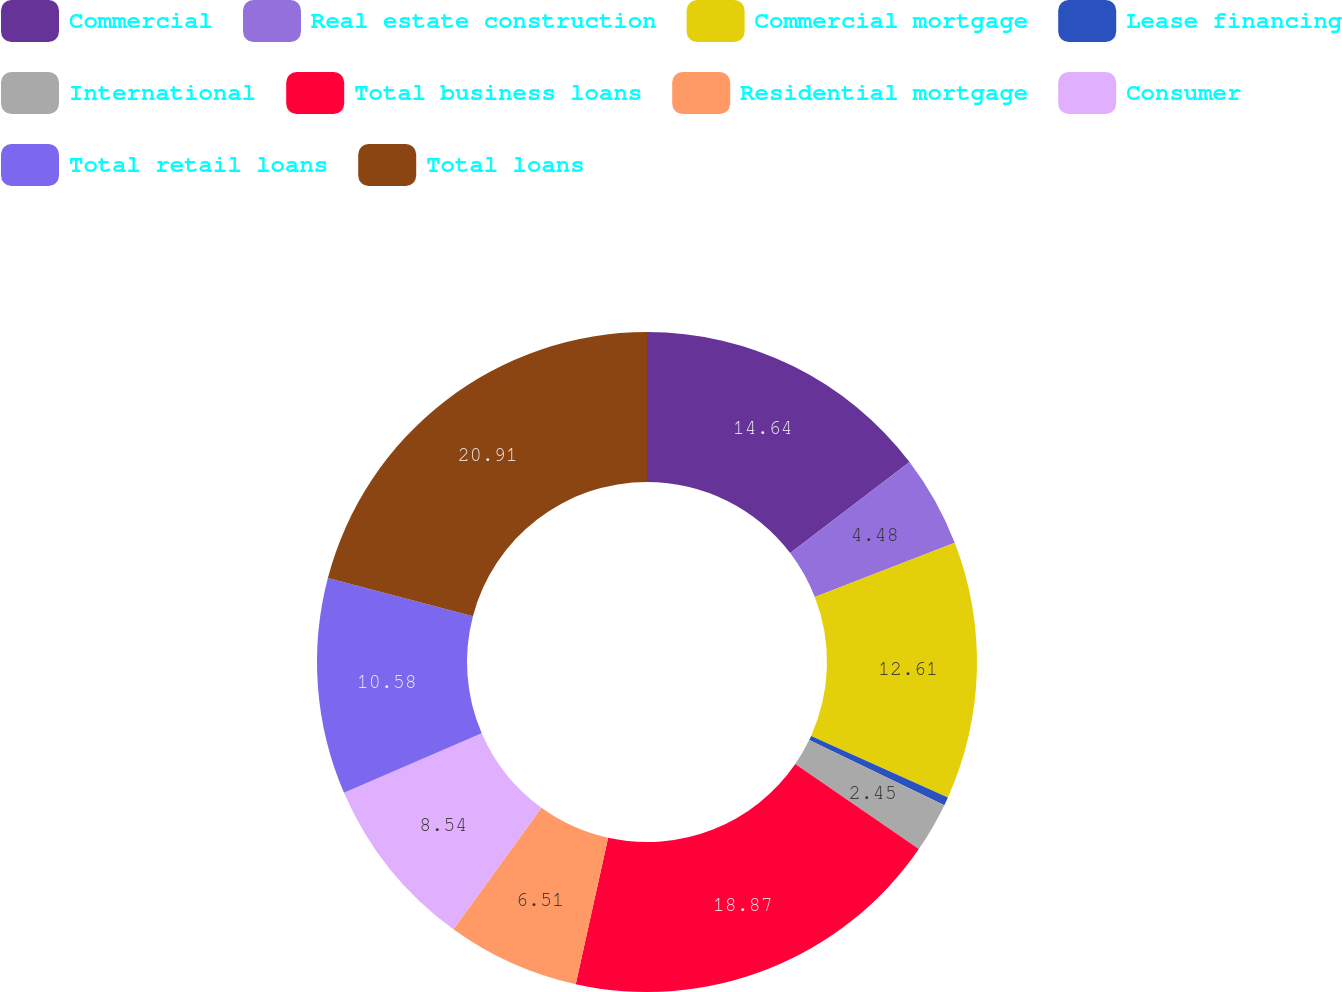Convert chart to OTSL. <chart><loc_0><loc_0><loc_500><loc_500><pie_chart><fcel>Commercial<fcel>Real estate construction<fcel>Commercial mortgage<fcel>Lease financing<fcel>International<fcel>Total business loans<fcel>Residential mortgage<fcel>Consumer<fcel>Total retail loans<fcel>Total loans<nl><fcel>14.64%<fcel>4.48%<fcel>12.61%<fcel>0.41%<fcel>2.45%<fcel>18.87%<fcel>6.51%<fcel>8.54%<fcel>10.58%<fcel>20.9%<nl></chart> 